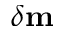<formula> <loc_0><loc_0><loc_500><loc_500>\delta m</formula> 